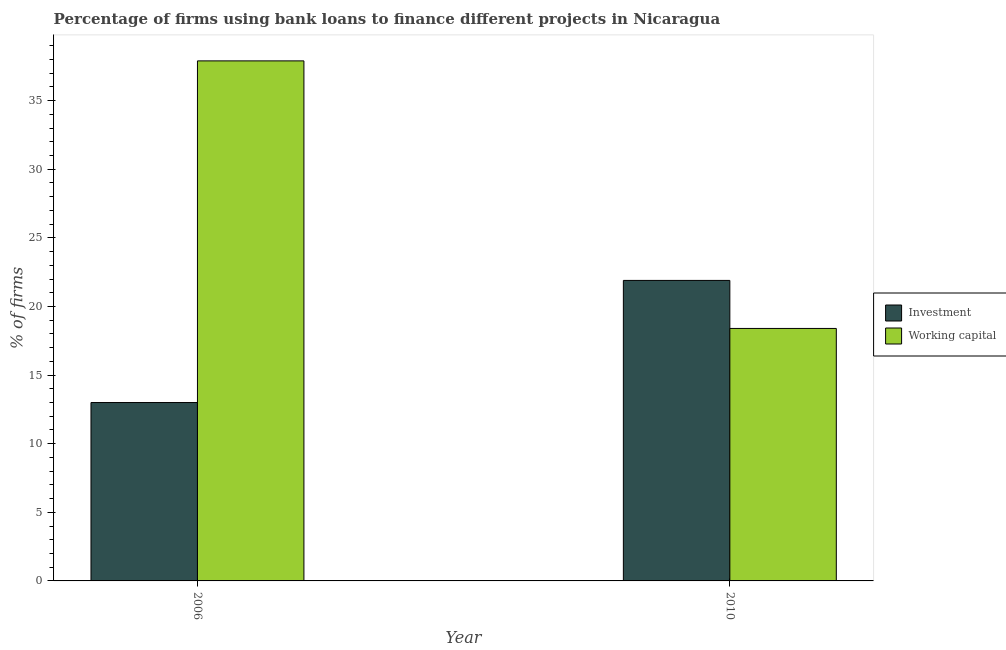How many different coloured bars are there?
Your response must be concise. 2. How many groups of bars are there?
Your answer should be compact. 2. Are the number of bars on each tick of the X-axis equal?
Your answer should be compact. Yes. What is the label of the 1st group of bars from the left?
Provide a succinct answer. 2006. In how many cases, is the number of bars for a given year not equal to the number of legend labels?
Provide a succinct answer. 0. Across all years, what is the maximum percentage of firms using banks to finance investment?
Make the answer very short. 21.9. Across all years, what is the minimum percentage of firms using banks to finance working capital?
Make the answer very short. 18.4. In which year was the percentage of firms using banks to finance investment minimum?
Give a very brief answer. 2006. What is the total percentage of firms using banks to finance investment in the graph?
Provide a short and direct response. 34.9. What is the difference between the percentage of firms using banks to finance working capital in 2006 and that in 2010?
Keep it short and to the point. 19.5. What is the difference between the percentage of firms using banks to finance working capital in 2010 and the percentage of firms using banks to finance investment in 2006?
Your response must be concise. -19.5. What is the average percentage of firms using banks to finance investment per year?
Provide a short and direct response. 17.45. In the year 2010, what is the difference between the percentage of firms using banks to finance investment and percentage of firms using banks to finance working capital?
Make the answer very short. 0. What is the ratio of the percentage of firms using banks to finance investment in 2006 to that in 2010?
Offer a terse response. 0.59. In how many years, is the percentage of firms using banks to finance working capital greater than the average percentage of firms using banks to finance working capital taken over all years?
Keep it short and to the point. 1. What does the 2nd bar from the left in 2010 represents?
Your answer should be compact. Working capital. What does the 2nd bar from the right in 2006 represents?
Provide a short and direct response. Investment. Are all the bars in the graph horizontal?
Offer a very short reply. No. What is the difference between two consecutive major ticks on the Y-axis?
Provide a short and direct response. 5. Does the graph contain any zero values?
Your answer should be very brief. No. How are the legend labels stacked?
Offer a terse response. Vertical. What is the title of the graph?
Offer a very short reply. Percentage of firms using bank loans to finance different projects in Nicaragua. What is the label or title of the X-axis?
Give a very brief answer. Year. What is the label or title of the Y-axis?
Your answer should be compact. % of firms. What is the % of firms of Investment in 2006?
Provide a short and direct response. 13. What is the % of firms in Working capital in 2006?
Your answer should be compact. 37.9. What is the % of firms of Investment in 2010?
Provide a short and direct response. 21.9. Across all years, what is the maximum % of firms of Investment?
Give a very brief answer. 21.9. Across all years, what is the maximum % of firms of Working capital?
Your response must be concise. 37.9. Across all years, what is the minimum % of firms of Working capital?
Make the answer very short. 18.4. What is the total % of firms of Investment in the graph?
Your response must be concise. 34.9. What is the total % of firms of Working capital in the graph?
Your response must be concise. 56.3. What is the difference between the % of firms in Investment in 2006 and the % of firms in Working capital in 2010?
Keep it short and to the point. -5.4. What is the average % of firms in Investment per year?
Give a very brief answer. 17.45. What is the average % of firms in Working capital per year?
Provide a short and direct response. 28.15. In the year 2006, what is the difference between the % of firms in Investment and % of firms in Working capital?
Keep it short and to the point. -24.9. In the year 2010, what is the difference between the % of firms in Investment and % of firms in Working capital?
Provide a short and direct response. 3.5. What is the ratio of the % of firms of Investment in 2006 to that in 2010?
Your answer should be compact. 0.59. What is the ratio of the % of firms in Working capital in 2006 to that in 2010?
Give a very brief answer. 2.06. What is the difference between the highest and the second highest % of firms of Investment?
Give a very brief answer. 8.9. What is the difference between the highest and the lowest % of firms in Working capital?
Keep it short and to the point. 19.5. 